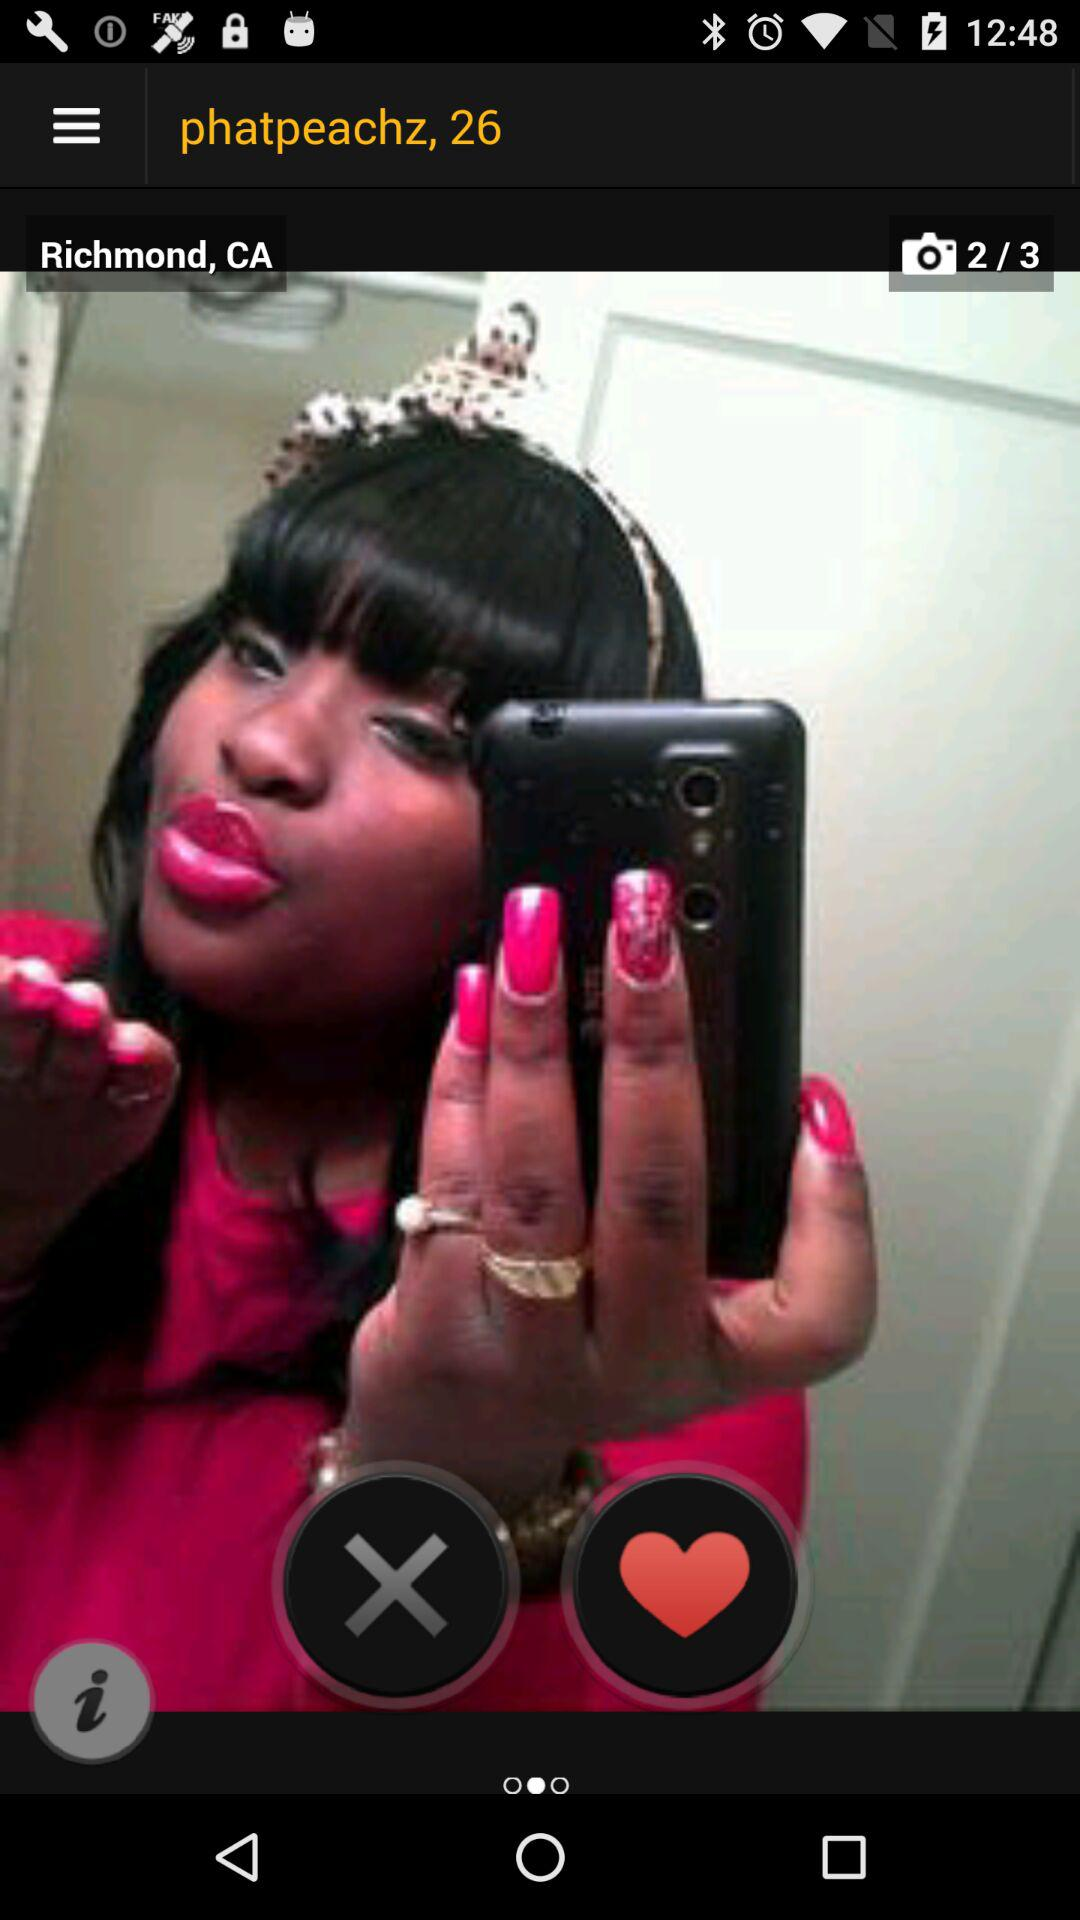How tall is "phatpeachz"?
When the provided information is insufficient, respond with <no answer>. <no answer> 